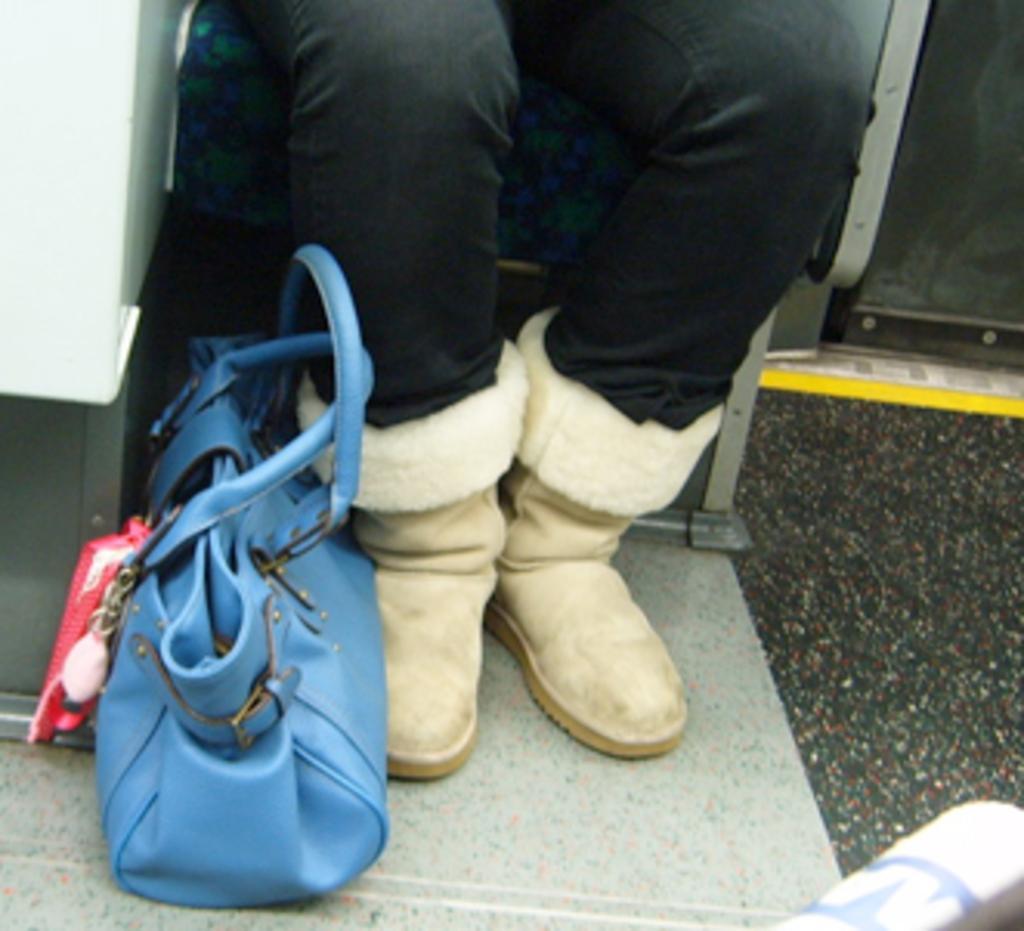Describe this image in one or two sentences. There is a blue colored leather handbag placed on the floor. These are the persons legs wearing a trouser and cream colored shoes. I think the person is sitting on the chair. I can see some pink colored object which is attached to the hand bag. 